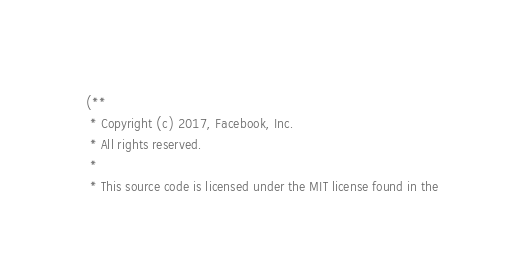<code> <loc_0><loc_0><loc_500><loc_500><_OCaml_>(**
 * Copyright (c) 2017, Facebook, Inc.
 * All rights reserved.
 *
 * This source code is licensed under the MIT license found in the</code> 